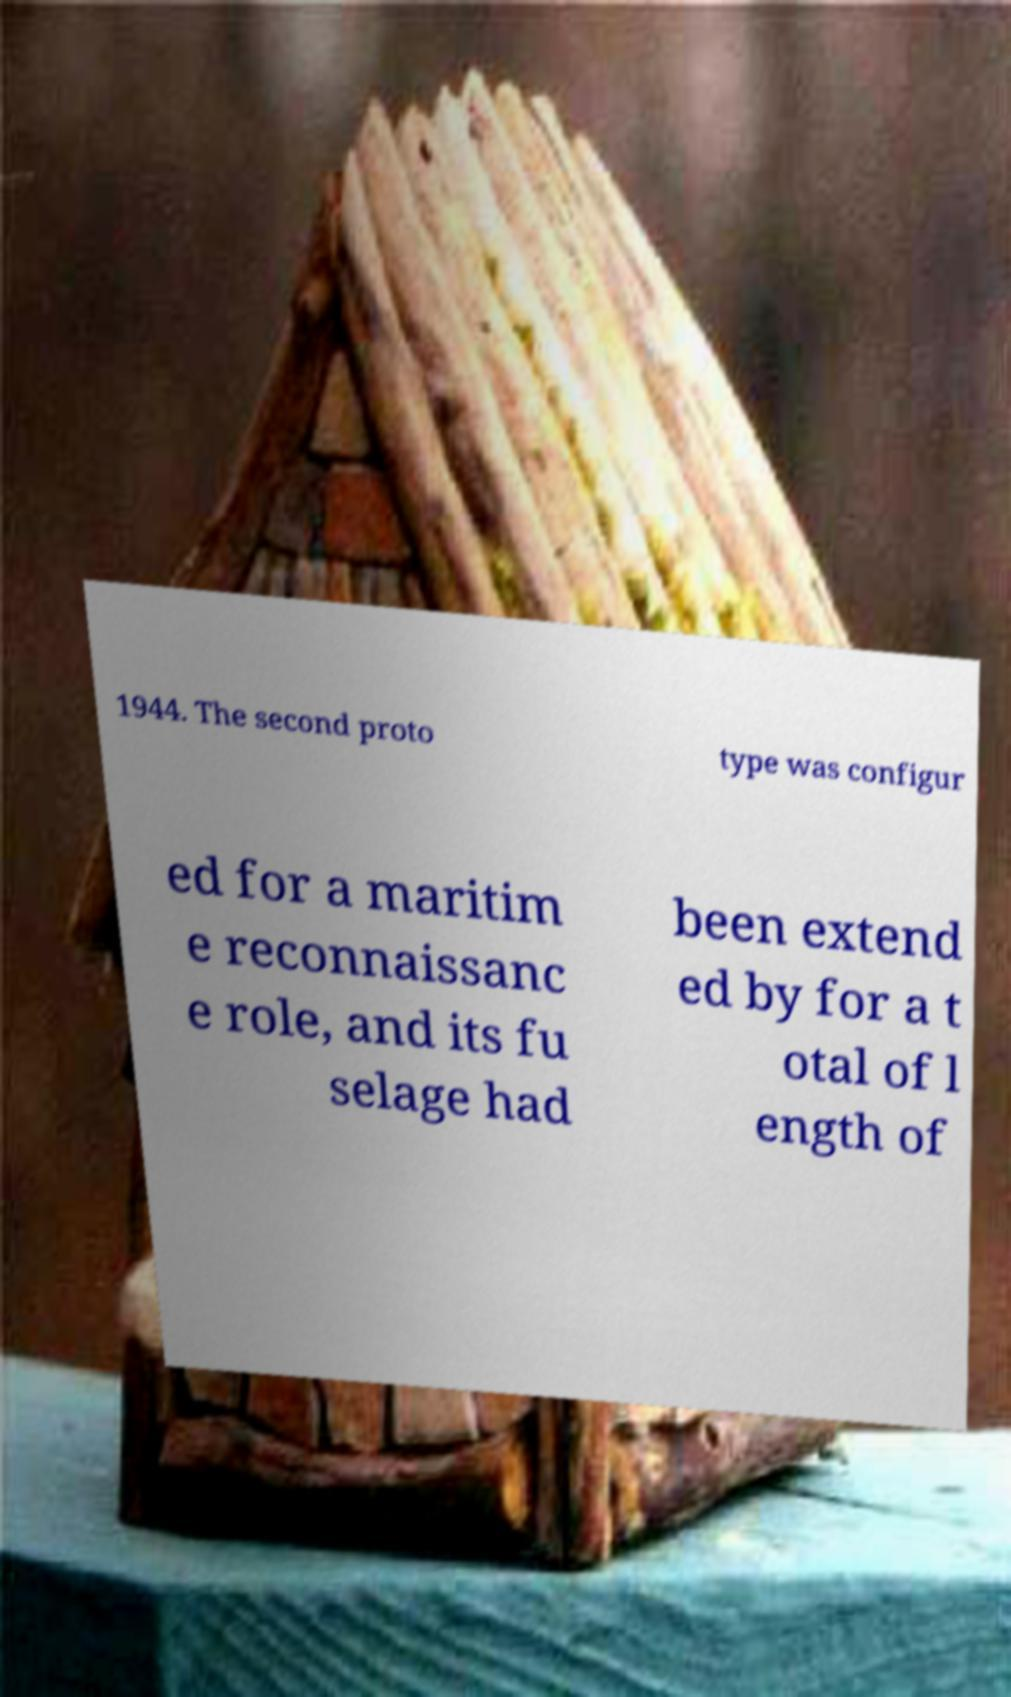Please read and relay the text visible in this image. What does it say? 1944. The second proto type was configur ed for a maritim e reconnaissanc e role, and its fu selage had been extend ed by for a t otal of l ength of 